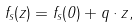Convert formula to latex. <formula><loc_0><loc_0><loc_500><loc_500>f _ { s } ( z ) = f _ { s } ( 0 ) + q \cdot z ,</formula> 